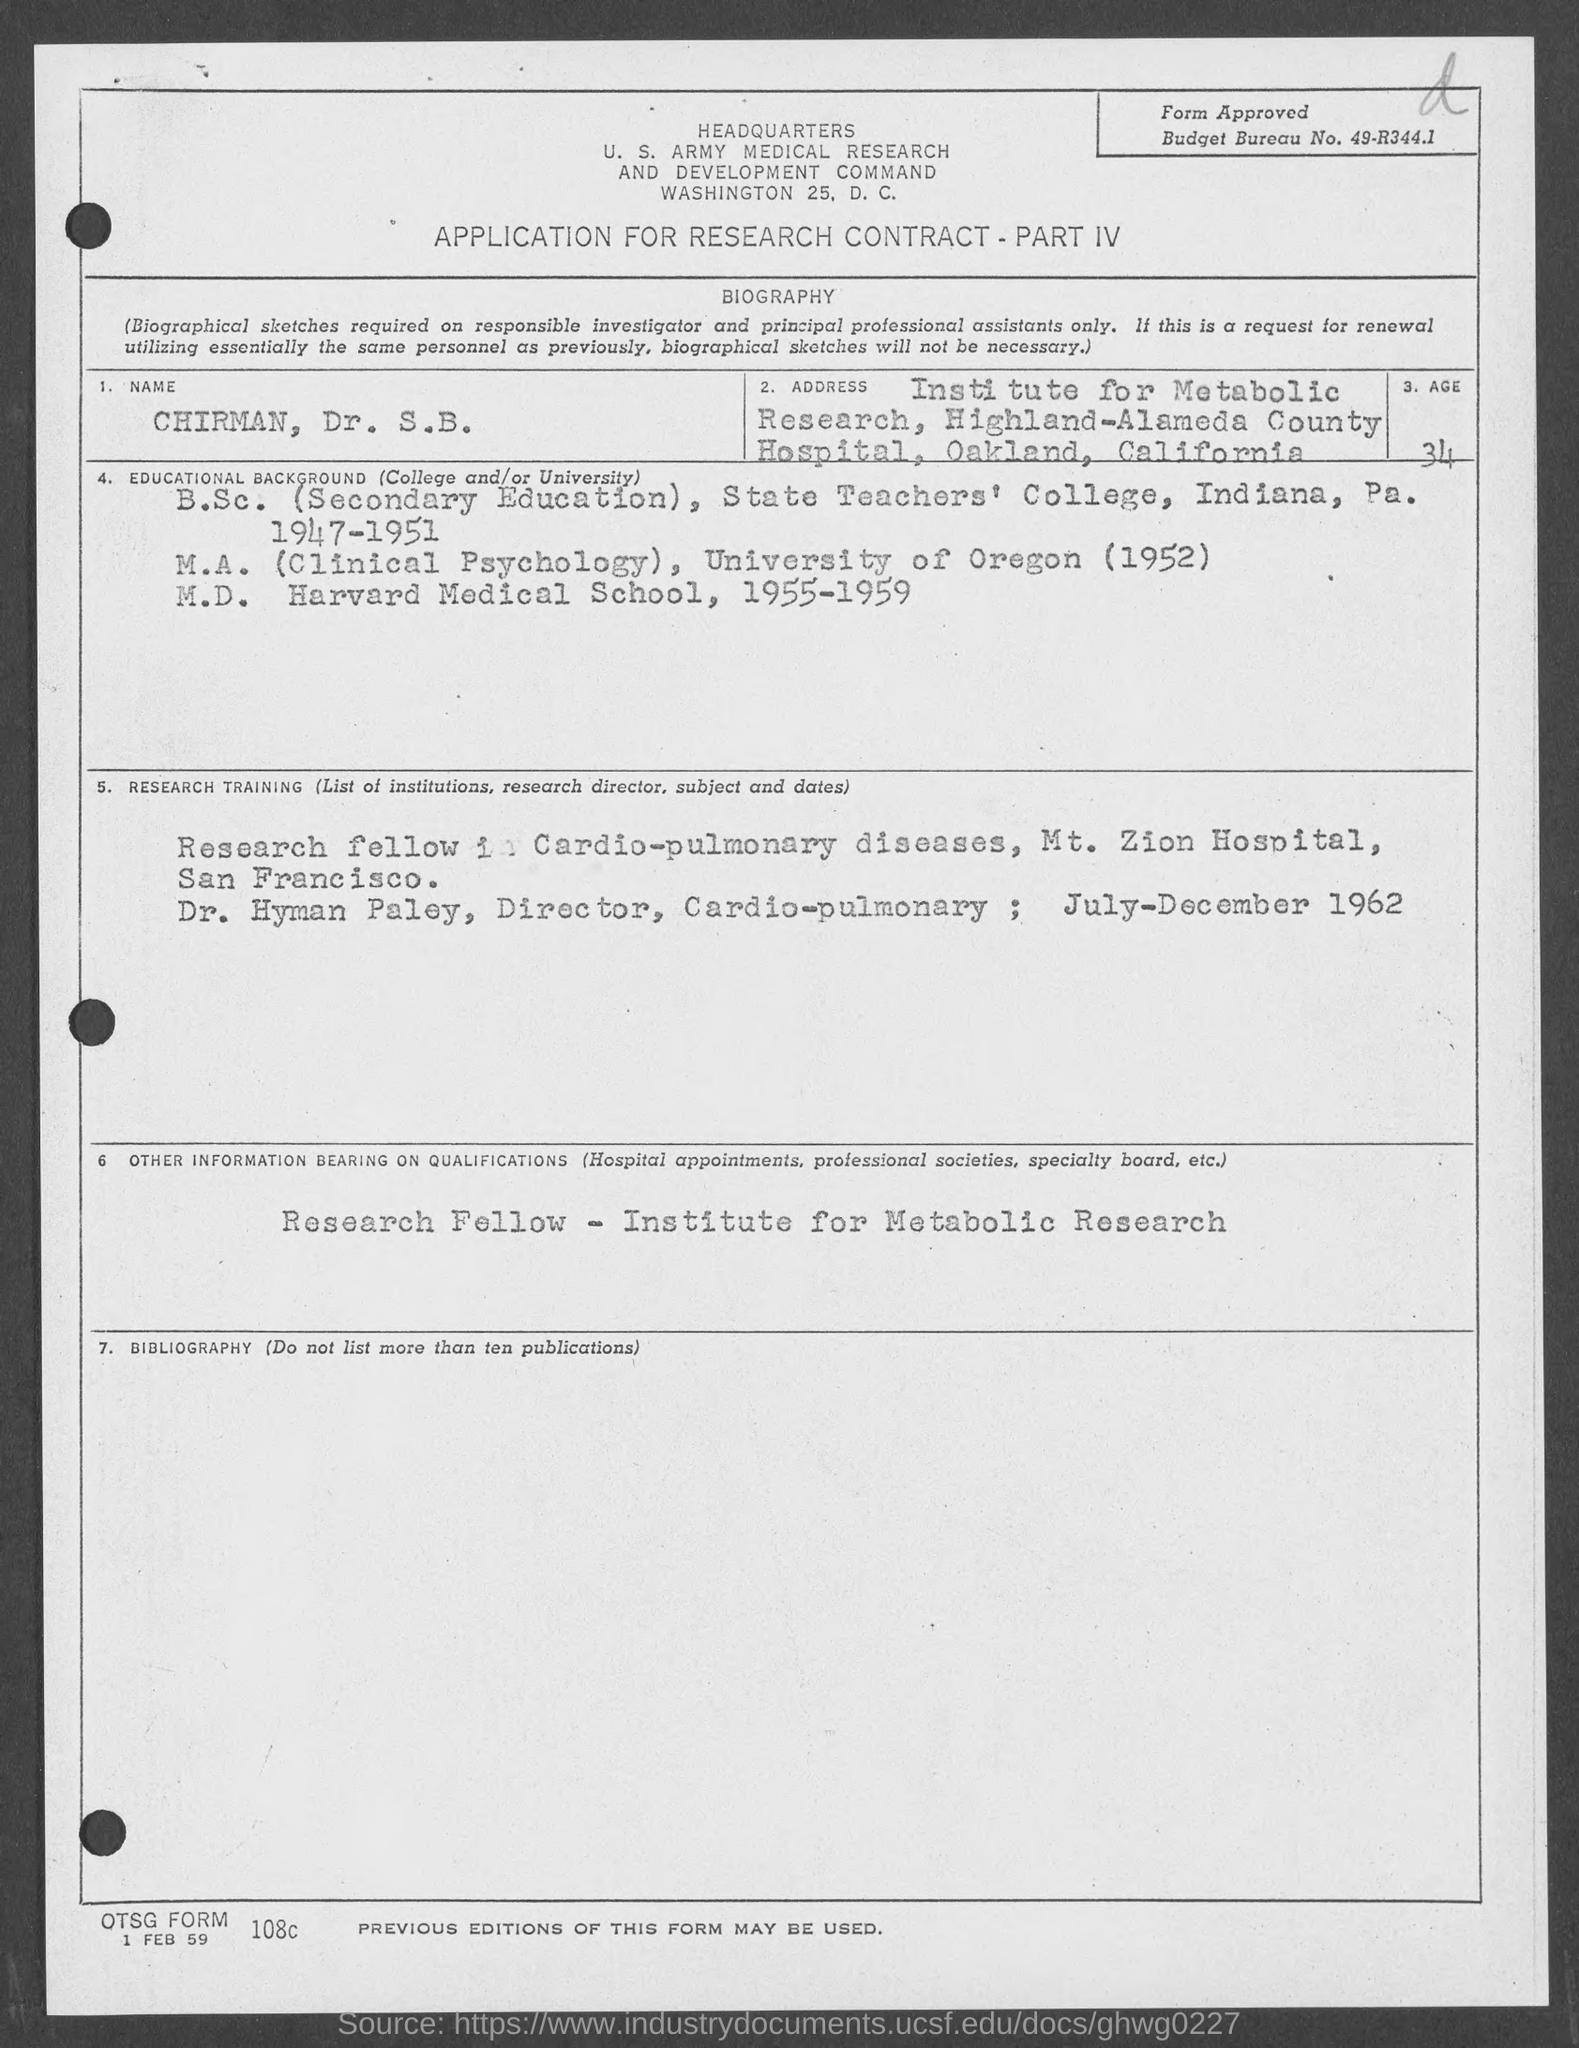Indicate a few pertinent items in this graphic. The applicant's age is 34. In 1952, the applicant completed his M.A. The budget bureau number is 49-R344.1. The name of the applicant in the form is Chairman, Dr. S.B... 